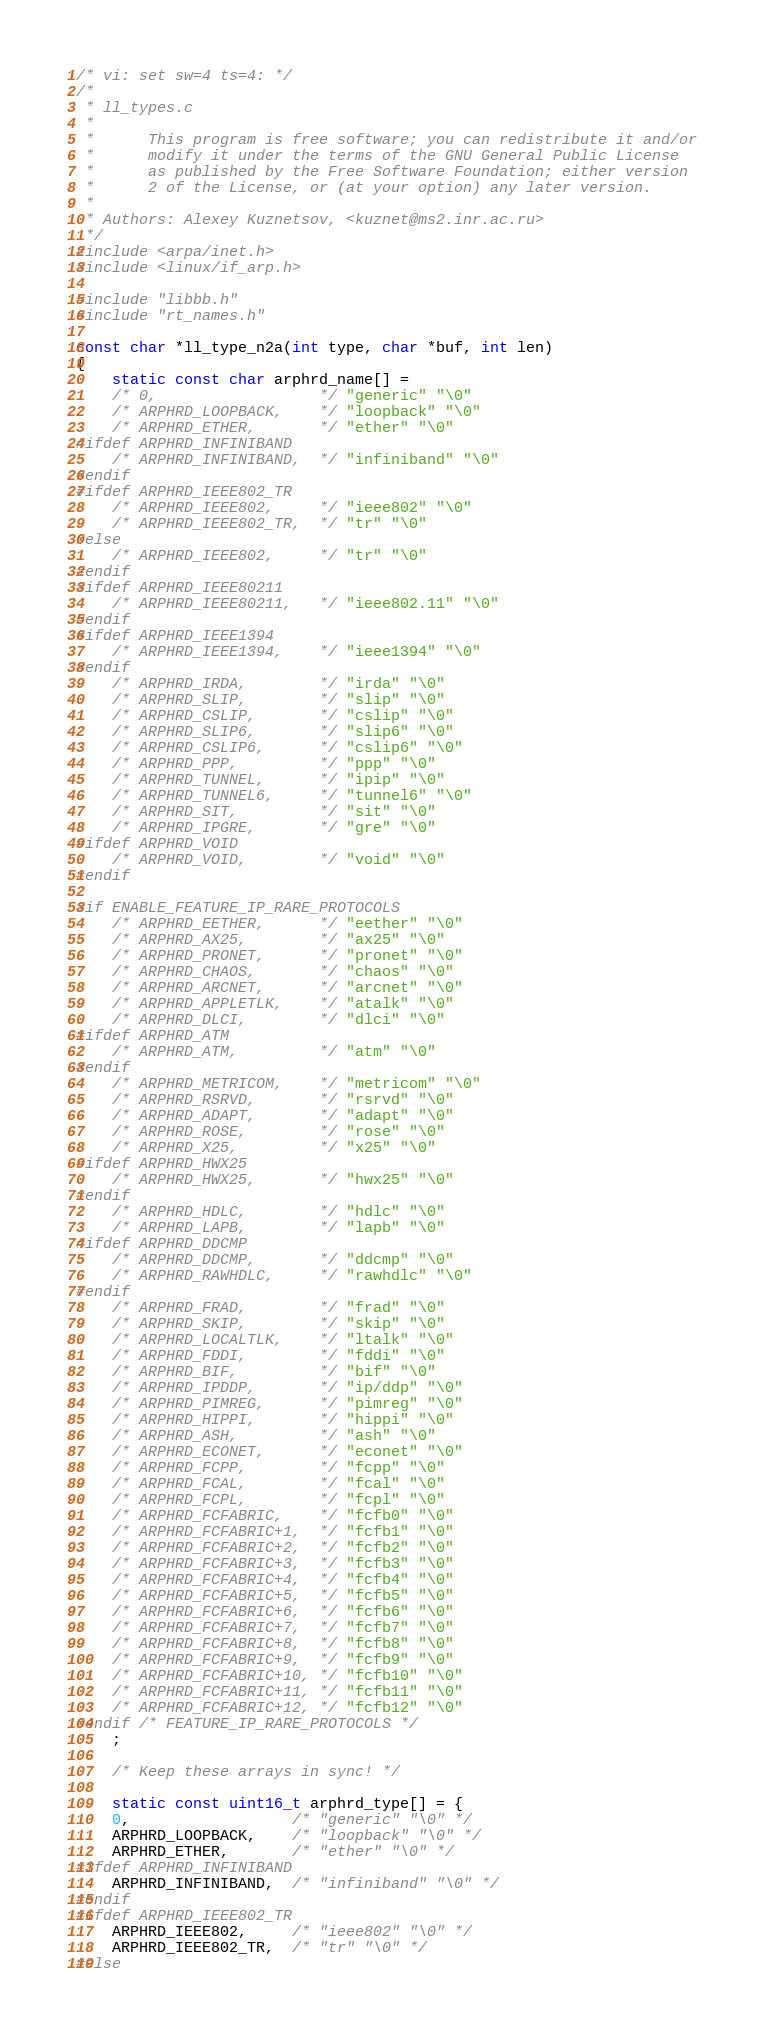<code> <loc_0><loc_0><loc_500><loc_500><_C_>/* vi: set sw=4 ts=4: */
/*
 * ll_types.c
 *
 *		This program is free software; you can redistribute it and/or
 *		modify it under the terms of the GNU General Public License
 *		as published by the Free Software Foundation; either version
 *		2 of the License, or (at your option) any later version.
 *
 * Authors:	Alexey Kuznetsov, <kuznet@ms2.inr.ac.ru>
 */
#include <arpa/inet.h>
#include <linux/if_arp.h>

#include "libbb.h"
#include "rt_names.h"

const char *ll_type_n2a(int type, char *buf, int len)
{
	static const char arphrd_name[] =
	/* 0,                  */ "generic" "\0"
	/* ARPHRD_LOOPBACK,    */ "loopback" "\0"
	/* ARPHRD_ETHER,       */ "ether" "\0"
#ifdef ARPHRD_INFINIBAND
	/* ARPHRD_INFINIBAND,  */ "infiniband" "\0"
#endif
#ifdef ARPHRD_IEEE802_TR
	/* ARPHRD_IEEE802,     */ "ieee802" "\0"
	/* ARPHRD_IEEE802_TR,  */ "tr" "\0"
#else
	/* ARPHRD_IEEE802,     */ "tr" "\0"
#endif
#ifdef ARPHRD_IEEE80211
	/* ARPHRD_IEEE80211,   */ "ieee802.11" "\0"
#endif
#ifdef ARPHRD_IEEE1394
	/* ARPHRD_IEEE1394,    */ "ieee1394" "\0"
#endif
	/* ARPHRD_IRDA,        */ "irda" "\0"
	/* ARPHRD_SLIP,        */ "slip" "\0"
	/* ARPHRD_CSLIP,       */ "cslip" "\0"
	/* ARPHRD_SLIP6,       */ "slip6" "\0"
	/* ARPHRD_CSLIP6,      */ "cslip6" "\0"
	/* ARPHRD_PPP,         */ "ppp" "\0"
	/* ARPHRD_TUNNEL,      */ "ipip" "\0"
	/* ARPHRD_TUNNEL6,     */ "tunnel6" "\0"
	/* ARPHRD_SIT,         */ "sit" "\0"
	/* ARPHRD_IPGRE,       */ "gre" "\0"
#ifdef ARPHRD_VOID
	/* ARPHRD_VOID,        */ "void" "\0"
#endif

#if ENABLE_FEATURE_IP_RARE_PROTOCOLS
	/* ARPHRD_EETHER,      */ "eether" "\0"
	/* ARPHRD_AX25,        */ "ax25" "\0"
	/* ARPHRD_PRONET,      */ "pronet" "\0"
	/* ARPHRD_CHAOS,       */ "chaos" "\0"
	/* ARPHRD_ARCNET,      */ "arcnet" "\0"
	/* ARPHRD_APPLETLK,    */ "atalk" "\0"
	/* ARPHRD_DLCI,        */ "dlci" "\0"
#ifdef ARPHRD_ATM
	/* ARPHRD_ATM,         */ "atm" "\0"
#endif
	/* ARPHRD_METRICOM,    */ "metricom" "\0"
	/* ARPHRD_RSRVD,       */ "rsrvd" "\0"
	/* ARPHRD_ADAPT,       */ "adapt" "\0"
	/* ARPHRD_ROSE,        */ "rose" "\0"
	/* ARPHRD_X25,         */ "x25" "\0"
#ifdef ARPHRD_HWX25
	/* ARPHRD_HWX25,       */ "hwx25" "\0"
#endif
	/* ARPHRD_HDLC,        */ "hdlc" "\0"
	/* ARPHRD_LAPB,        */ "lapb" "\0"
#ifdef ARPHRD_DDCMP
	/* ARPHRD_DDCMP,       */ "ddcmp" "\0"
	/* ARPHRD_RAWHDLC,     */ "rawhdlc" "\0"
#endif
	/* ARPHRD_FRAD,        */ "frad" "\0"
	/* ARPHRD_SKIP,        */ "skip" "\0"
	/* ARPHRD_LOCALTLK,    */ "ltalk" "\0"
	/* ARPHRD_FDDI,        */ "fddi" "\0"
	/* ARPHRD_BIF,         */ "bif" "\0"
	/* ARPHRD_IPDDP,       */ "ip/ddp" "\0"
	/* ARPHRD_PIMREG,      */ "pimreg" "\0"
	/* ARPHRD_HIPPI,       */ "hippi" "\0"
	/* ARPHRD_ASH,         */ "ash" "\0"
	/* ARPHRD_ECONET,      */ "econet" "\0"
	/* ARPHRD_FCPP,        */ "fcpp" "\0"
	/* ARPHRD_FCAL,        */ "fcal" "\0"
	/* ARPHRD_FCPL,        */ "fcpl" "\0"
	/* ARPHRD_FCFABRIC,    */ "fcfb0" "\0"
	/* ARPHRD_FCFABRIC+1,  */ "fcfb1" "\0"
	/* ARPHRD_FCFABRIC+2,  */ "fcfb2" "\0"
	/* ARPHRD_FCFABRIC+3,  */ "fcfb3" "\0"
	/* ARPHRD_FCFABRIC+4,  */ "fcfb4" "\0"
	/* ARPHRD_FCFABRIC+5,  */ "fcfb5" "\0"
	/* ARPHRD_FCFABRIC+6,  */ "fcfb6" "\0"
	/* ARPHRD_FCFABRIC+7,  */ "fcfb7" "\0"
	/* ARPHRD_FCFABRIC+8,  */ "fcfb8" "\0"
	/* ARPHRD_FCFABRIC+9,  */ "fcfb9" "\0"
	/* ARPHRD_FCFABRIC+10, */ "fcfb10" "\0"
	/* ARPHRD_FCFABRIC+11, */ "fcfb11" "\0"
	/* ARPHRD_FCFABRIC+12, */ "fcfb12" "\0"
#endif /* FEATURE_IP_RARE_PROTOCOLS */
	;

	/* Keep these arrays in sync! */

	static const uint16_t arphrd_type[] = {
	0,                  /* "generic" "\0" */
	ARPHRD_LOOPBACK,    /* "loopback" "\0" */
	ARPHRD_ETHER,       /* "ether" "\0" */
#ifdef ARPHRD_INFINIBAND
	ARPHRD_INFINIBAND,  /* "infiniband" "\0" */
#endif
#ifdef ARPHRD_IEEE802_TR
	ARPHRD_IEEE802,     /* "ieee802" "\0" */
	ARPHRD_IEEE802_TR,  /* "tr" "\0" */
#else</code> 